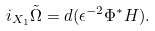<formula> <loc_0><loc_0><loc_500><loc_500>\label l { e q \colon d y n } i _ { X _ { 1 } } \tilde { \Omega } = d ( \epsilon ^ { - 2 } \Phi ^ { * } H ) .</formula> 